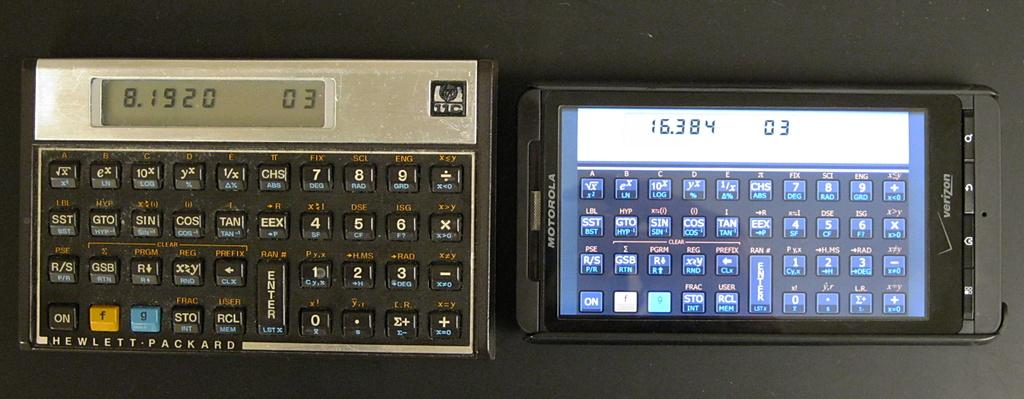<image>
Write a terse but informative summary of the picture. Motorola phone next to a Hewlett Packard calculator. 